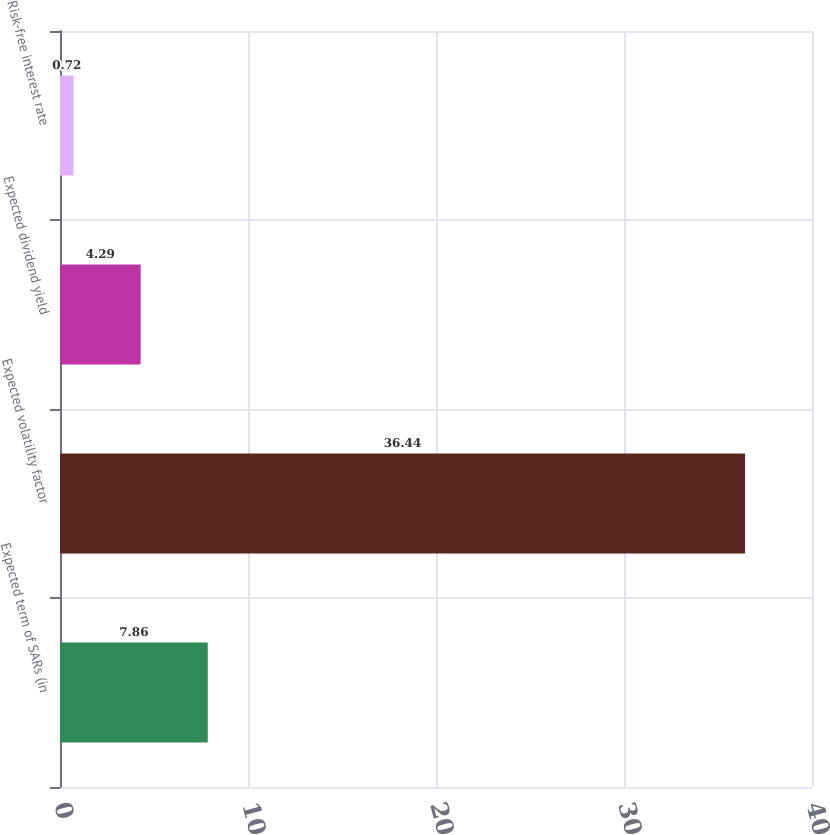Convert chart. <chart><loc_0><loc_0><loc_500><loc_500><bar_chart><fcel>Expected term of SARs (in<fcel>Expected volatility factor<fcel>Expected dividend yield<fcel>Risk-free interest rate<nl><fcel>7.86<fcel>36.44<fcel>4.29<fcel>0.72<nl></chart> 